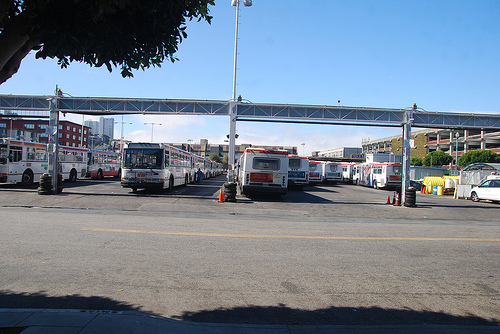Are there any buses?
Answer the question using a single word or phrase. Yes What vehicle is to the right of the cone? Bus Are there both cars and buses in this picture? Yes On which side of the picture is the car? Right 